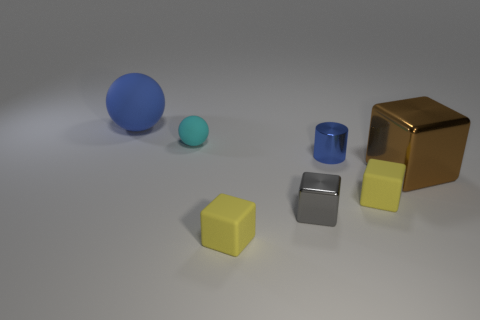Subtract all small shiny cubes. How many cubes are left? 3 Add 2 tiny gray blocks. How many objects exist? 9 Subtract all blue balls. How many balls are left? 1 Subtract all cylinders. How many objects are left? 6 Subtract all cyan balls. Subtract all blue cylinders. How many balls are left? 1 Subtract all green cubes. How many red cylinders are left? 0 Subtract all large green shiny cylinders. Subtract all small yellow matte cubes. How many objects are left? 5 Add 1 big blue rubber things. How many big blue rubber things are left? 2 Add 4 cyan balls. How many cyan balls exist? 5 Subtract 0 brown spheres. How many objects are left? 7 